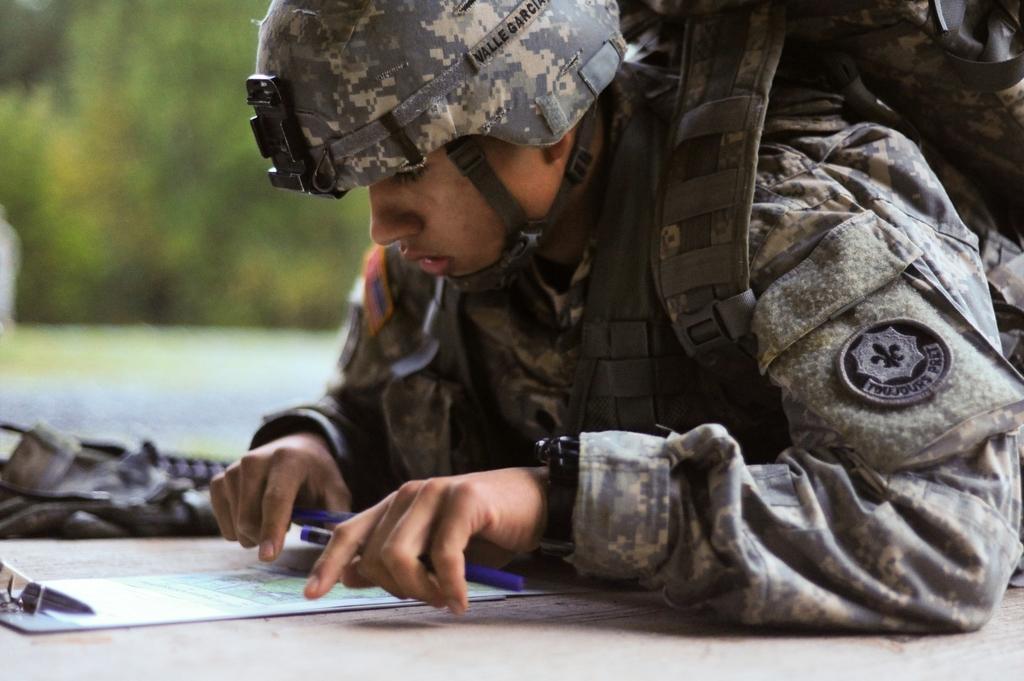Describe this image in one or two sentences. Here I can see a person wearing uniform, bag, cap on the head and laying on the floor and also looking at a paper which is on the ground. I can see a pen in his hand. Beside this person there is a cloth on the floor. The background is blurry. 